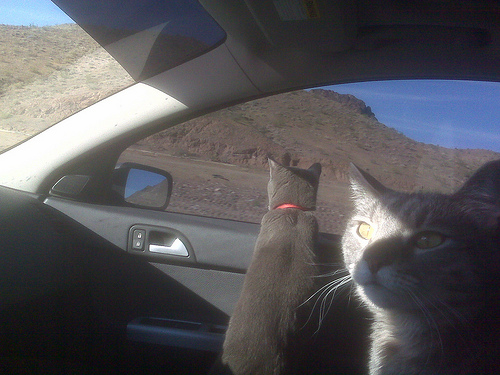<image>
Is there a cat on the cat? No. The cat is not positioned on the cat. They may be near each other, but the cat is not supported by or resting on top of the cat. Is the cat in front of the car? No. The cat is not in front of the car. The spatial positioning shows a different relationship between these objects. 